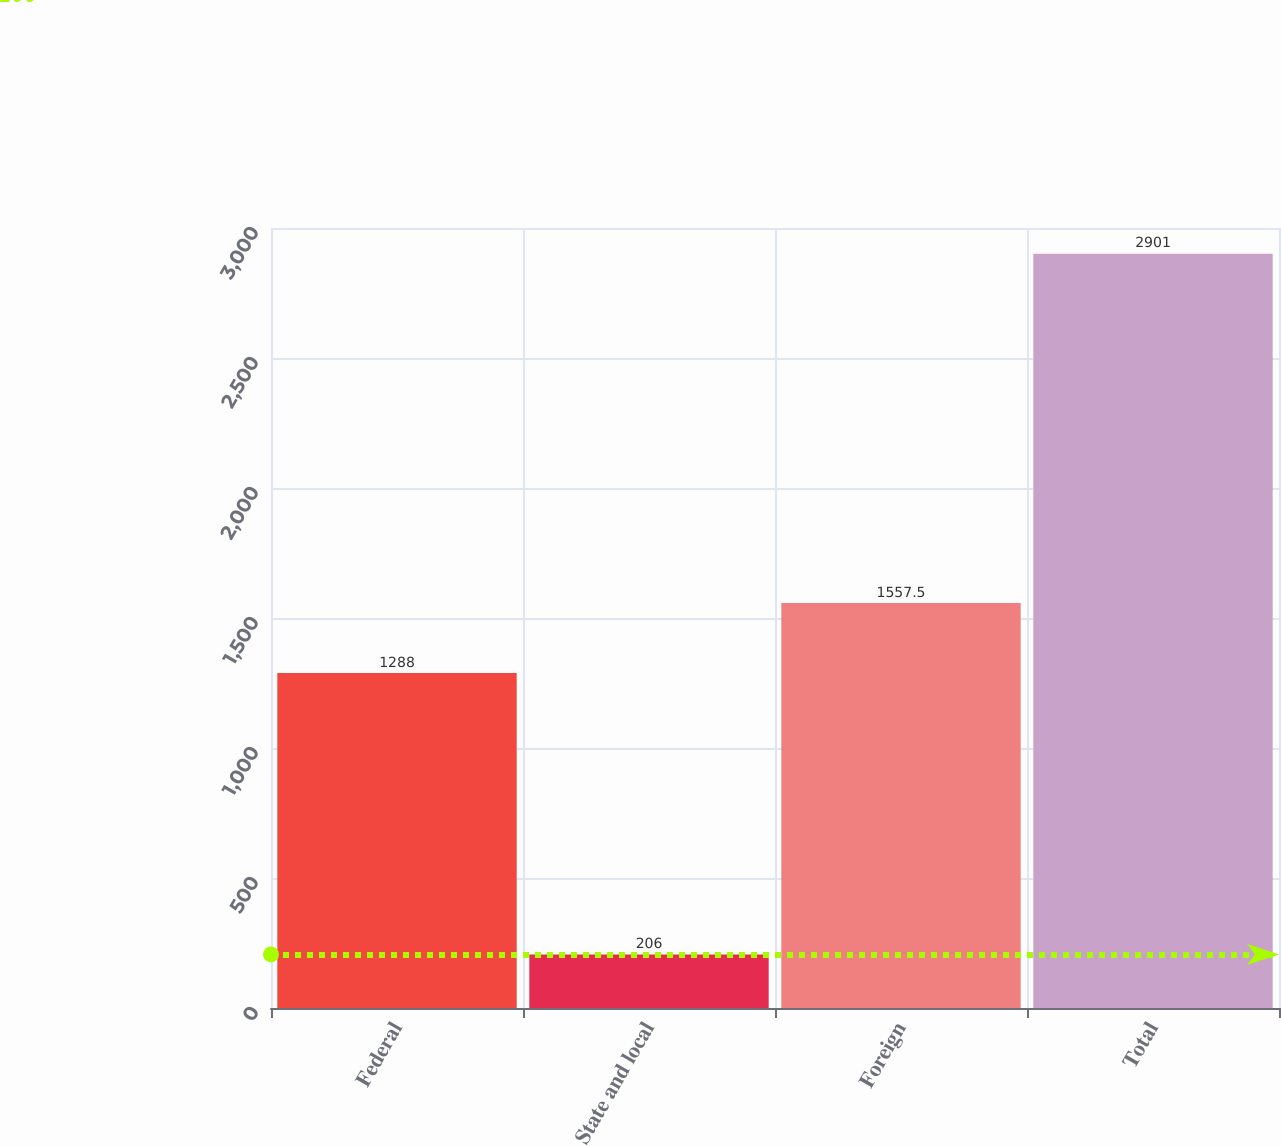<chart> <loc_0><loc_0><loc_500><loc_500><bar_chart><fcel>Federal<fcel>State and local<fcel>Foreign<fcel>Total<nl><fcel>1288<fcel>206<fcel>1557.5<fcel>2901<nl></chart> 